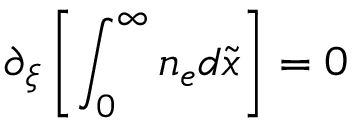Convert formula to latex. <formula><loc_0><loc_0><loc_500><loc_500>\partial _ { \xi } \left [ \int _ { 0 } ^ { \infty } n _ { e } d \tilde { x } \right ] = 0</formula> 